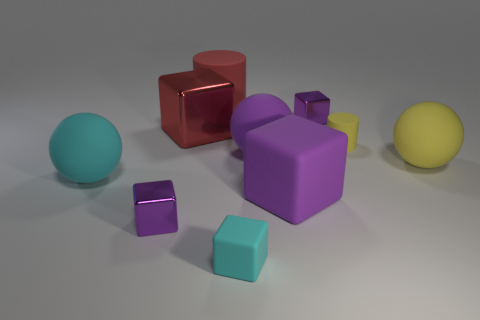How many purple cubes must be subtracted to get 1 purple cubes? 2 Subtract all purple blocks. How many blocks are left? 2 Subtract all tiny cyan cubes. How many cubes are left? 4 Subtract all yellow cylinders. How many purple spheres are left? 1 Subtract all purple rubber spheres. Subtract all tiny blocks. How many objects are left? 6 Add 5 small cylinders. How many small cylinders are left? 6 Add 1 small cyan cubes. How many small cyan cubes exist? 2 Subtract 1 yellow cylinders. How many objects are left? 9 Subtract all cylinders. How many objects are left? 8 Subtract 1 spheres. How many spheres are left? 2 